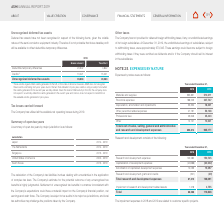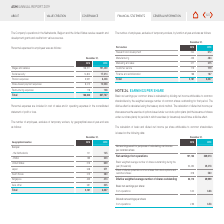From Asm International Nv's financial document, Which countries that the company operates in receive research and development grants and credits? The document contains multiple relevant values: Netherlands, Belgium, the United States. From the document: "The Company’s operations in the Netherlands, Belgium and the United States receive research and The Netherlands 2014 - 2019 pany’s operations in the N..." Also, What are the years that information regarding Research and development is provided? The document shows two values: 2018 and 2019. From the document: "2018 2019 2018 2019..." Also, What is the  Research and development expenses for 2018? According to the financial document, 125,280. The relevant text states: "Research and development expenses 125,280 150,745..." Additionally, Which year had the higher total research and development expense? According to the financial document, 2019. The relevant text states: "2018 2019..." Also, can you calculate: What is the change in total Research and development expenses? Based on the calculation: 110,846-88,588, the result is 22258. This is based on the information: "Total 88,588 110,846 Total 88,588 110,846..." The key data points involved are: 110,846, 88,588. Also, can you calculate: What is the percentage change in total Research and development expenses? To answer this question, I need to perform calculations using the financial data. The calculation is: (110,846-88,588)/88,588, which equals 25.13 (percentage). This is based on the information: "Total 88,588 110,846 Total 88,588 110,846..." The key data points involved are: 110,846, 88,588. 